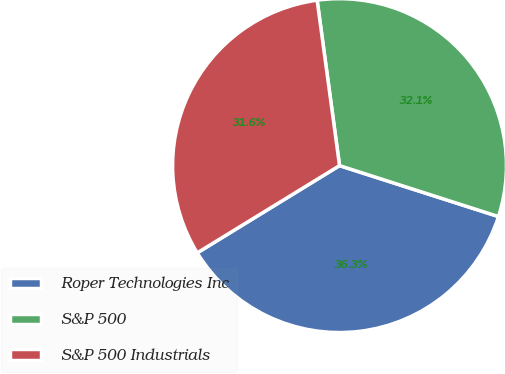Convert chart. <chart><loc_0><loc_0><loc_500><loc_500><pie_chart><fcel>Roper Technologies Inc<fcel>S&P 500<fcel>S&P 500 Industrials<nl><fcel>36.31%<fcel>32.08%<fcel>31.61%<nl></chart> 